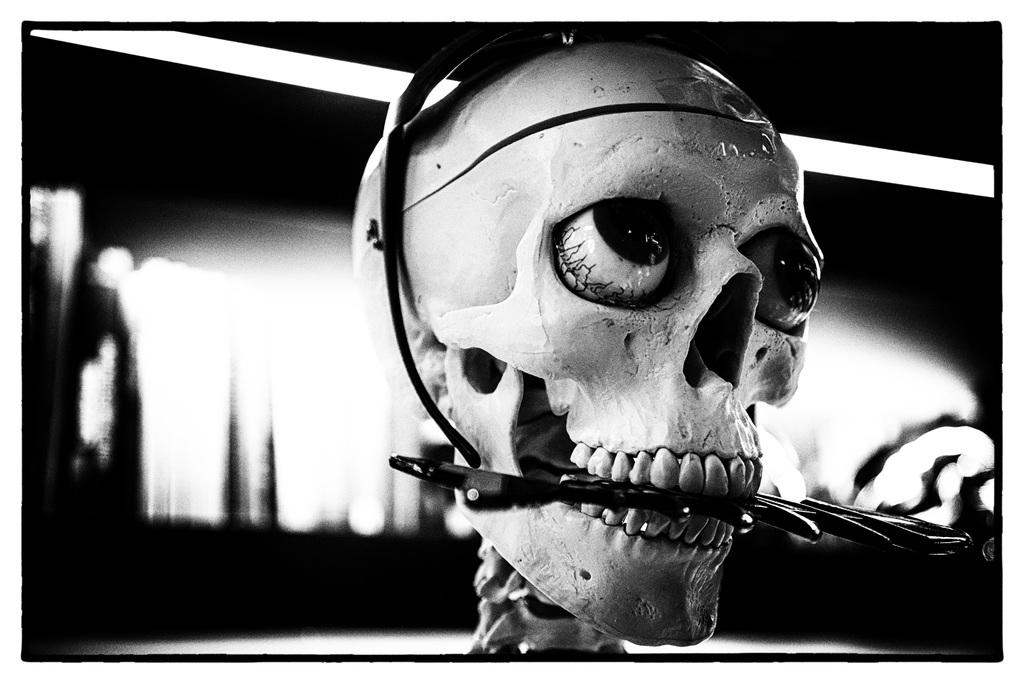What is the color scheme of the image? The image is black and white. What is the main subject of the image? There is a skull in the image. Can you describe the object between the teeth of the skull? Yes, there appears to be an object between the teeth of the skull. How would you describe the background of the image? The background of the image is blurry. Is there a veil covering the skull in the image? No, there is no veil present in the image. How many points does the skull have on its forehead in the image? The image is black and white, and the skull does not have any points on its forehead. 